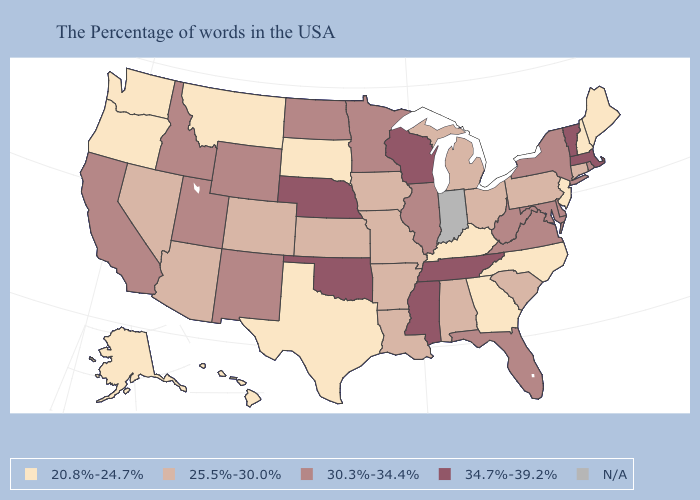What is the value of Kentucky?
Keep it brief. 20.8%-24.7%. Does the map have missing data?
Be succinct. Yes. Among the states that border North Dakota , does Minnesota have the lowest value?
Concise answer only. No. What is the value of Alaska?
Answer briefly. 20.8%-24.7%. Among the states that border Indiana , which have the highest value?
Answer briefly. Illinois. What is the highest value in the MidWest ?
Answer briefly. 34.7%-39.2%. What is the highest value in states that border Nebraska?
Short answer required. 30.3%-34.4%. Name the states that have a value in the range 20.8%-24.7%?
Short answer required. Maine, New Hampshire, New Jersey, North Carolina, Georgia, Kentucky, Texas, South Dakota, Montana, Washington, Oregon, Alaska, Hawaii. Name the states that have a value in the range 20.8%-24.7%?
Keep it brief. Maine, New Hampshire, New Jersey, North Carolina, Georgia, Kentucky, Texas, South Dakota, Montana, Washington, Oregon, Alaska, Hawaii. Name the states that have a value in the range 30.3%-34.4%?
Short answer required. Rhode Island, New York, Delaware, Maryland, Virginia, West Virginia, Florida, Illinois, Minnesota, North Dakota, Wyoming, New Mexico, Utah, Idaho, California. What is the value of North Carolina?
Give a very brief answer. 20.8%-24.7%. Which states hav the highest value in the MidWest?
Keep it brief. Wisconsin, Nebraska. What is the highest value in the South ?
Concise answer only. 34.7%-39.2%. 